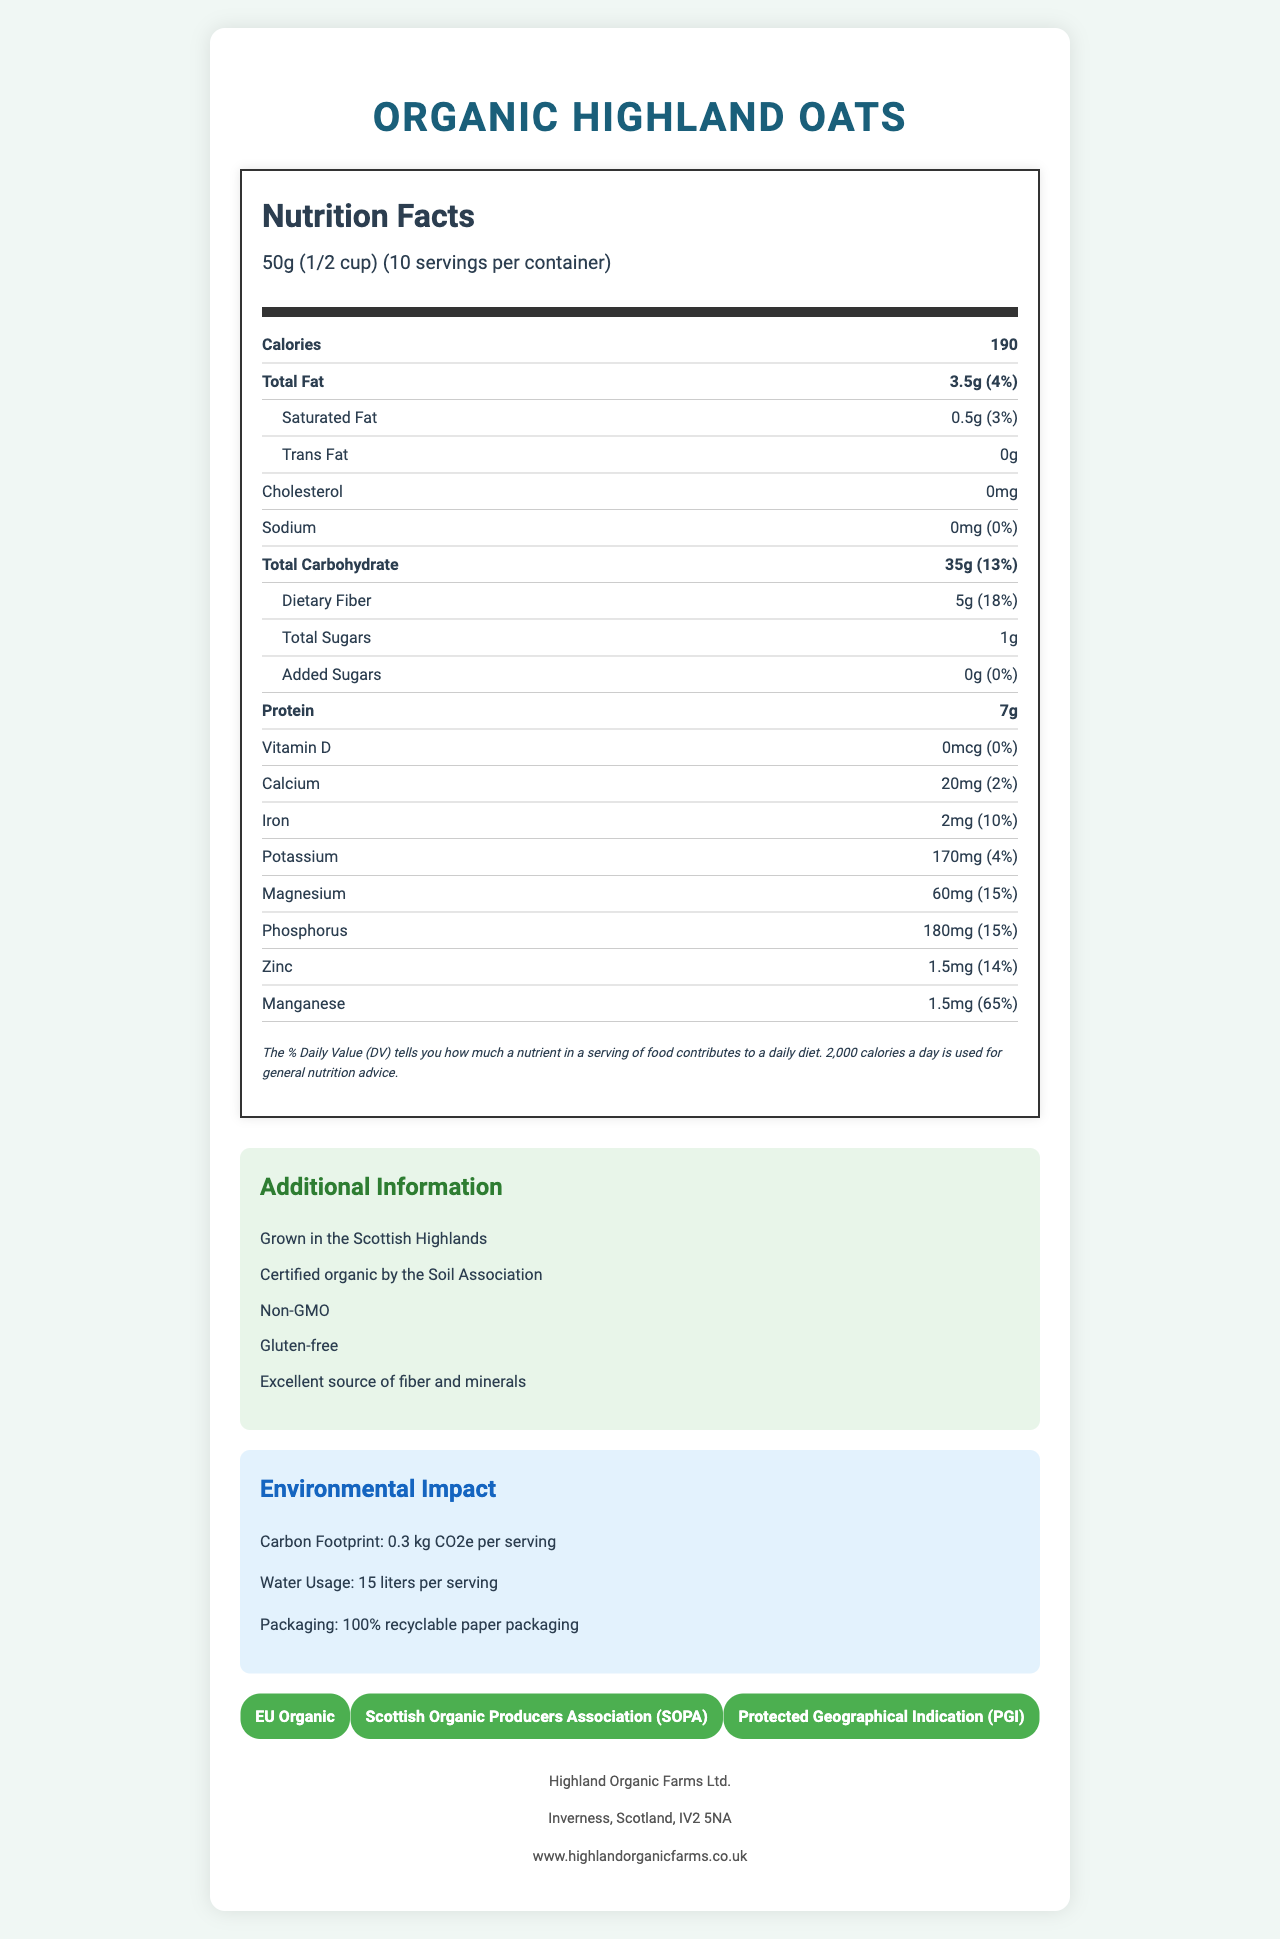how many grams of dietary fiber are there per serving? The document specifies that there are 5 grams of dietary fiber per serving.
Answer: 5g what is the percent daily value of manganese per serving? The document states that the percent daily value of manganese per serving is 65%.
Answer: 65% how much magnesium is in each serving? According to the document, each serving contains 60 milligrams of magnesium.
Answer: 60mg does the product contain any trans fat? The document indicates that there is 0g of trans fat per serving.
Answer: No how many calories are there per serving of Organic Highland Oats? The document lists that each serving contains 190 calories.
Answer: 190 organic highland oats are reported to be excellent sources of which nutrients? A. Fiber and Vitamins B. Fiber and Minerals C. Vitamins and Minerals D. Protein and Sodium According to the additional information, these oats are excellent sources of fiber and minerals.
Answer: B which mineral contributes the highest % daily value per serving? A. Iron B. Potassium C. Manganese D. Magnesium Manganese contributes 65% daily value per serving, the highest among the minerals listed.
Answer: C is calcium content more than iron content in the product? The document states there is 20mg of calcium (2% daily value) and 2mg of iron (10% daily value). Iron contributes more percent daily value than calcium.
Answer: No what is the summary of the document? The nutrition facts label highlights the nutritional content, including fiber and mineral content, and provides additional information on the product's environmental footprint and quality certifications.
Answer: Summary: The document is a detailed nutrition facts label for Organic Highland Oats. It provides information on serving size, calories, various nutrients and their amounts, percent daily values, and details about minerals and fiber content. It also includes additional information about the product's environmental impact, certifications, and manufacturer details. is the product grown using organic farming methods? The document mentions that the oats are certified organic by the Soil Association.
Answer: Yes what is the primary source to determine if the oats are gluten-free? The Additional Information section of the document clearly states the product is gluten-free.
Answer: Additional Information section does the document provide the carbon footprint of Organic Highland Oats? The environmental impact section states that the carbon footprint is 0.3 kg CO2e per serving.
Answer: Yes how many servings are there per container? The document specifies that there are 10 servings per container.
Answer: 10 what is the weight of one serving size? The document lists the serving size as 50g, which is equivalent to 1/2 cup.
Answer: 50g (1/2 cup) does the document include information on the total sales of the product? The document does not contain any details regarding the total sales of the product.
Answer: Not enough information 